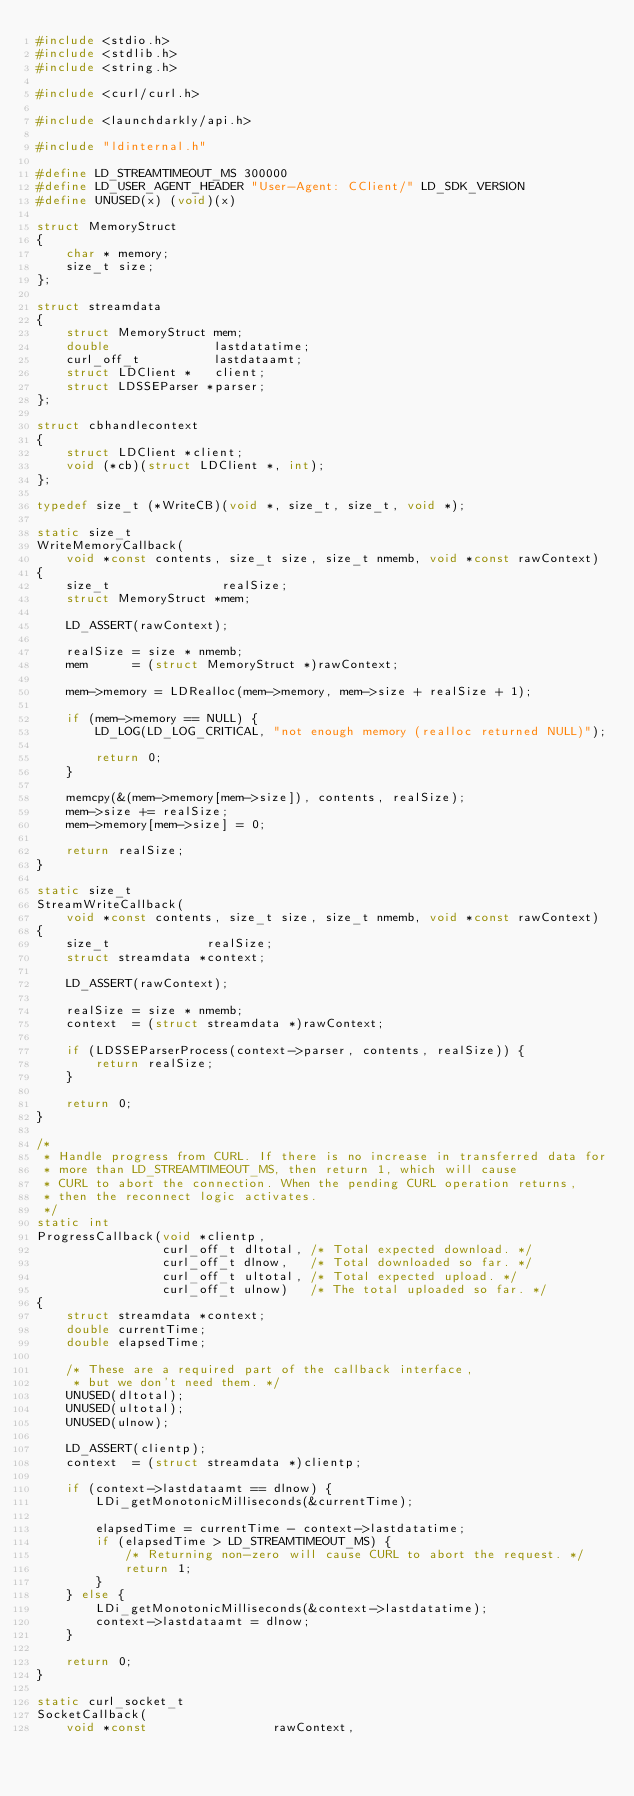Convert code to text. <code><loc_0><loc_0><loc_500><loc_500><_C_>#include <stdio.h>
#include <stdlib.h>
#include <string.h>

#include <curl/curl.h>

#include <launchdarkly/api.h>

#include "ldinternal.h"

#define LD_STREAMTIMEOUT_MS 300000
#define LD_USER_AGENT_HEADER "User-Agent: CClient/" LD_SDK_VERSION
#define UNUSED(x) (void)(x)

struct MemoryStruct
{
    char * memory;
    size_t size;
};

struct streamdata
{
    struct MemoryStruct mem;
    double              lastdatatime;
    curl_off_t          lastdataamt;
    struct LDClient *   client;
    struct LDSSEParser *parser;
};

struct cbhandlecontext
{
    struct LDClient *client;
    void (*cb)(struct LDClient *, int);
};

typedef size_t (*WriteCB)(void *, size_t, size_t, void *);

static size_t
WriteMemoryCallback(
    void *const contents, size_t size, size_t nmemb, void *const rawContext)
{
    size_t               realSize;
    struct MemoryStruct *mem;

    LD_ASSERT(rawContext);

    realSize = size * nmemb;
    mem      = (struct MemoryStruct *)rawContext;

    mem->memory = LDRealloc(mem->memory, mem->size + realSize + 1);

    if (mem->memory == NULL) {
        LD_LOG(LD_LOG_CRITICAL, "not enough memory (realloc returned NULL)");

        return 0;
    }

    memcpy(&(mem->memory[mem->size]), contents, realSize);
    mem->size += realSize;
    mem->memory[mem->size] = 0;

    return realSize;
}

static size_t
StreamWriteCallback(
    void *const contents, size_t size, size_t nmemb, void *const rawContext)
{
    size_t             realSize;
    struct streamdata *context;

    LD_ASSERT(rawContext);

    realSize = size * nmemb;
    context  = (struct streamdata *)rawContext;

    if (LDSSEParserProcess(context->parser, contents, realSize)) {
        return realSize;
    }

    return 0;
}

/*
 * Handle progress from CURL. If there is no increase in transferred data for
 * more than LD_STREAMTIMEOUT_MS, then return 1, which will cause
 * CURL to abort the connection. When the pending CURL operation returns,
 * then the reconnect logic activates.
 */
static int
ProgressCallback(void *clientp,
                 curl_off_t dltotal, /* Total expected download. */
                 curl_off_t dlnow,   /* Total downloaded so far. */
                 curl_off_t ultotal, /* Total expected upload. */
                 curl_off_t ulnow)   /* The total uploaded so far. */
{
    struct streamdata *context;
    double currentTime;
    double elapsedTime;

    /* These are a required part of the callback interface,
     * but we don't need them. */
    UNUSED(dltotal);
    UNUSED(ultotal);
    UNUSED(ulnow);

    LD_ASSERT(clientp);
    context  = (struct streamdata *)clientp;

    if (context->lastdataamt == dlnow) {
        LDi_getMonotonicMilliseconds(&currentTime);

        elapsedTime = currentTime - context->lastdatatime;
        if (elapsedTime > LD_STREAMTIMEOUT_MS) {
            /* Returning non-zero will cause CURL to abort the request. */
            return 1;
        }
    } else {
        LDi_getMonotonicMilliseconds(&context->lastdatatime);
        context->lastdataamt = dlnow;
    }

    return 0;
}

static curl_socket_t
SocketCallback(
    void *const                 rawContext,</code> 